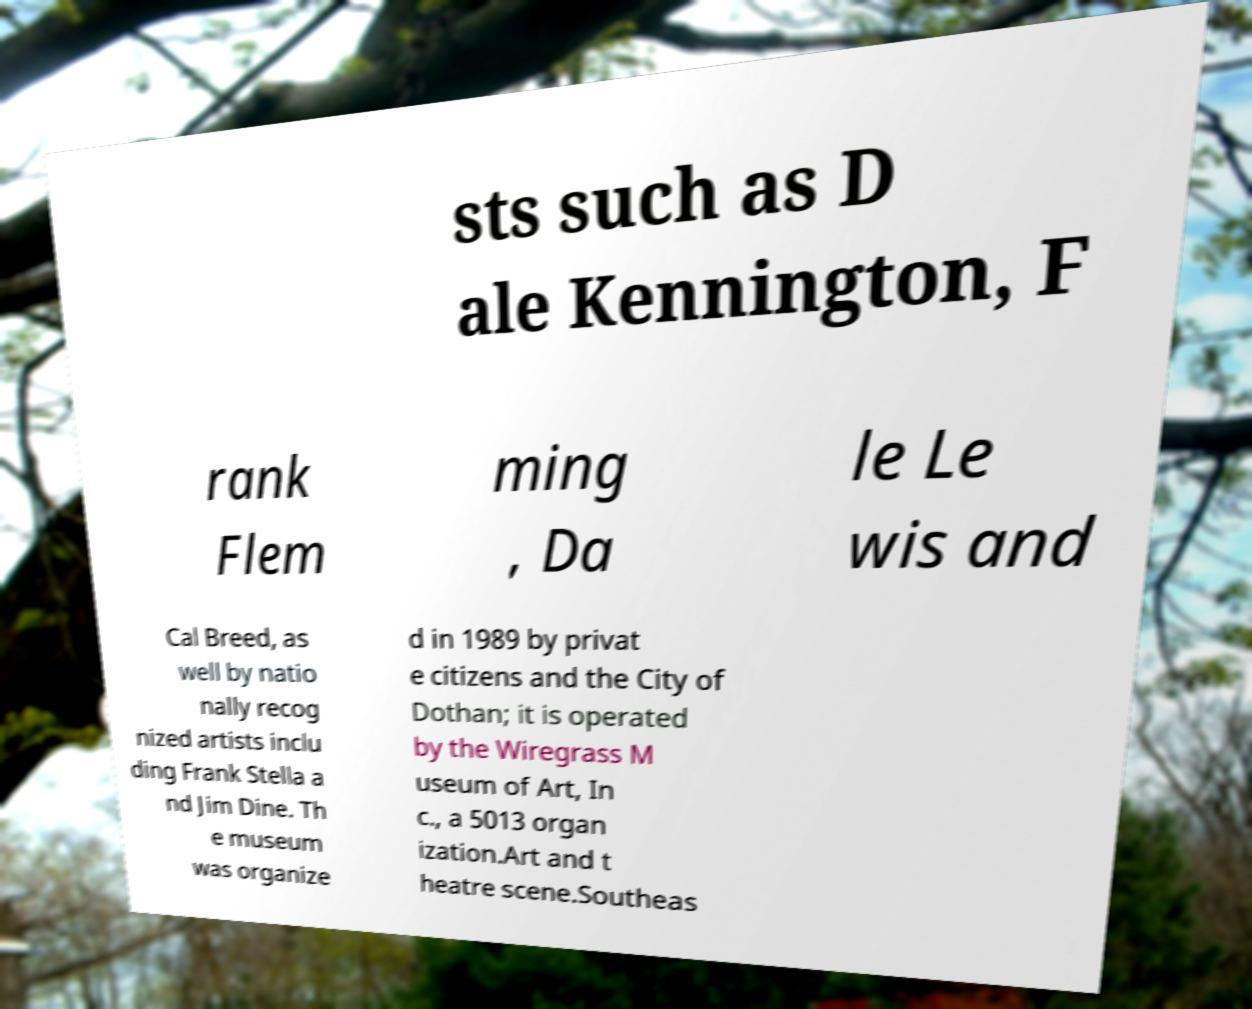I need the written content from this picture converted into text. Can you do that? sts such as D ale Kennington, F rank Flem ming , Da le Le wis and Cal Breed, as well by natio nally recog nized artists inclu ding Frank Stella a nd Jim Dine. Th e museum was organize d in 1989 by privat e citizens and the City of Dothan; it is operated by the Wiregrass M useum of Art, In c., a 5013 organ ization.Art and t heatre scene.Southeas 